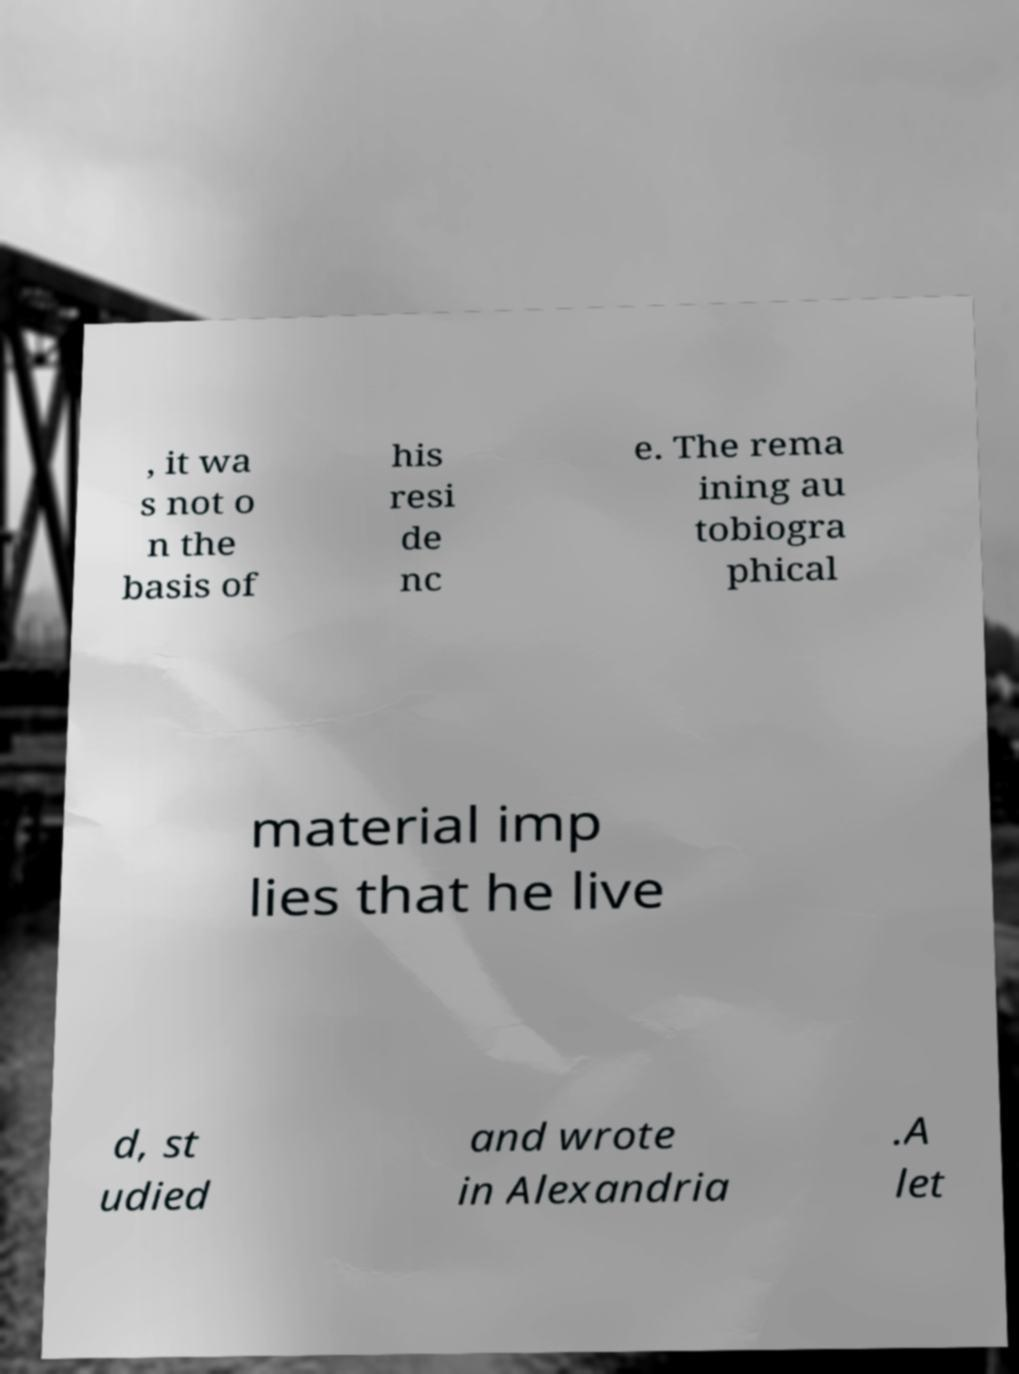For documentation purposes, I need the text within this image transcribed. Could you provide that? , it wa s not o n the basis of his resi de nc e. The rema ining au tobiogra phical material imp lies that he live d, st udied and wrote in Alexandria .A let 